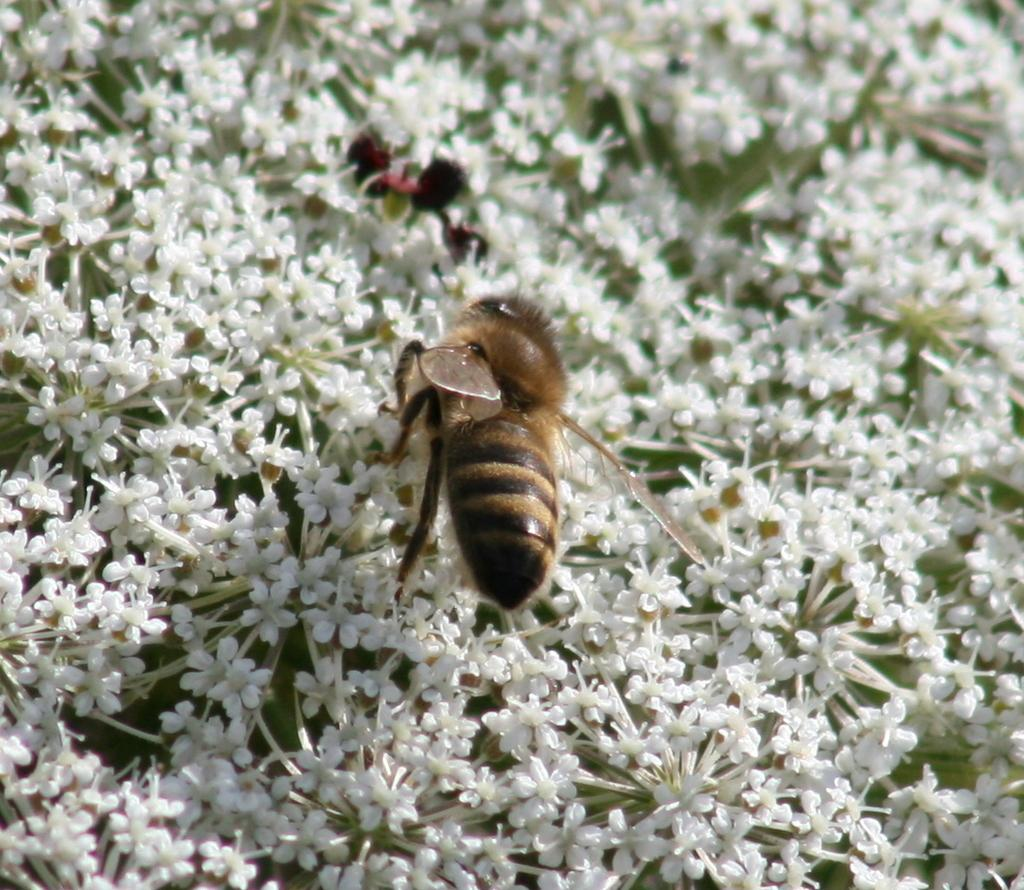What is the main subject of the picture? The main subject of the picture is an insect. What is the insect sitting on? The insect is on white flowers. Can you describe the background of the image? The background of the image is blurry. What type of quilt is being used to cover the grandmother in the image? There is no grandmother or quilt present in the image; it features an insect on white flowers with a blurry background. 